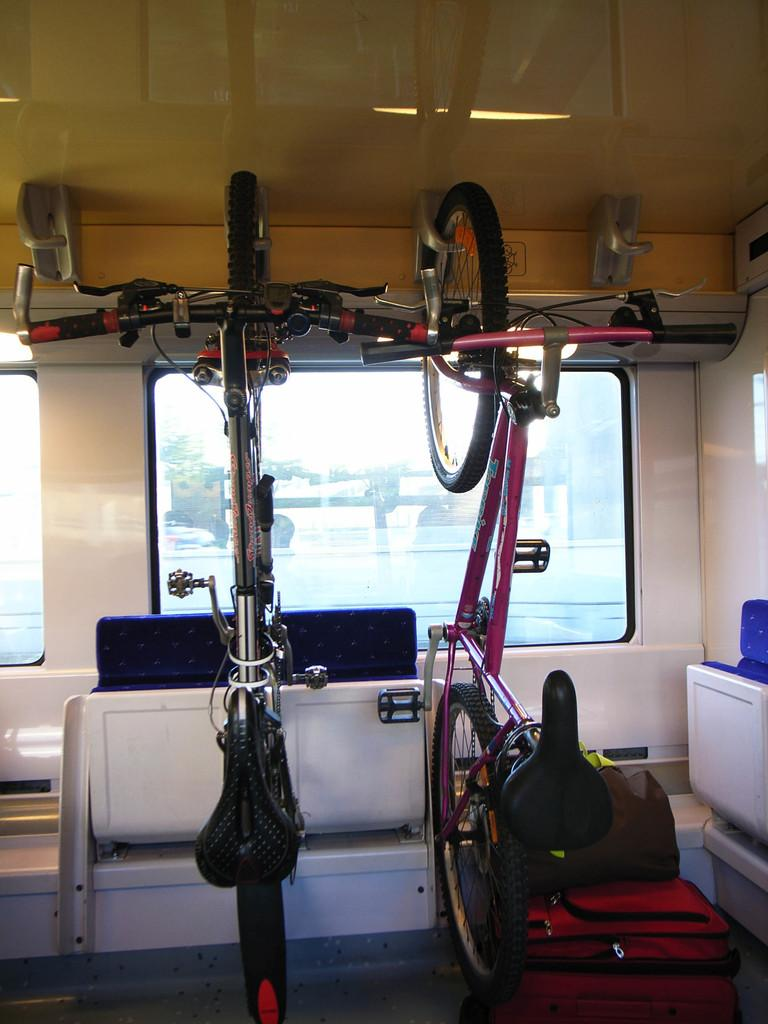What objects are hanging in the foreground of the image? There are two bicycles hanging on a hanger in the foreground. What can be seen in the background of the image? There is a table, a window, trees, and a rooftop visible in the background. How might the image have been captured? The image may have been taken inside a vehicle. What type of force can be seen affecting the waves on the sand in the image? There are no waves or sand present in the image; it features bicycles hanging on a hanger and a background with a table, window, trees, and a rooftop. 